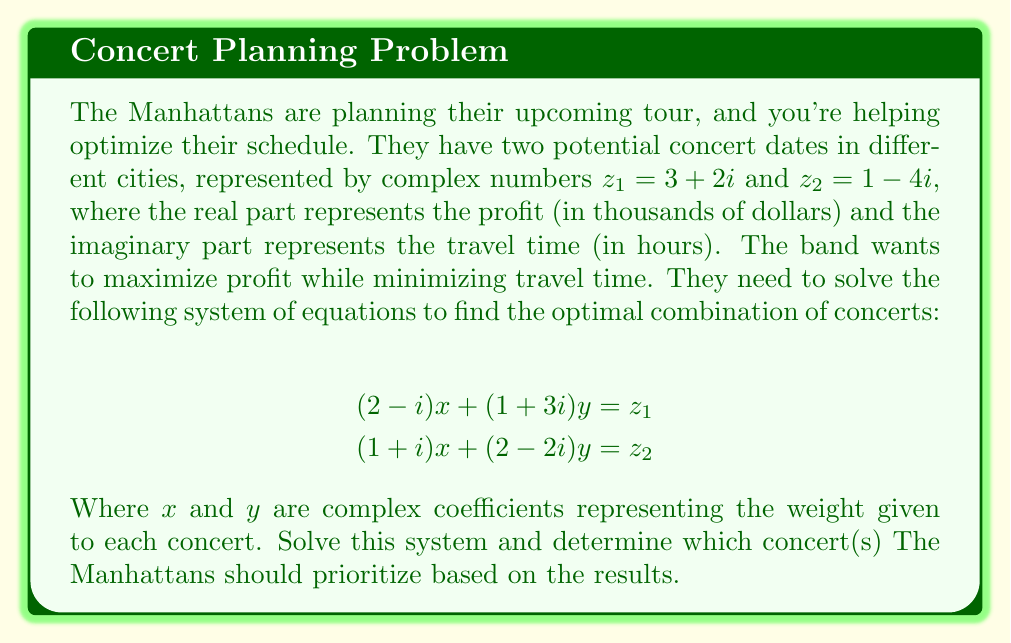What is the answer to this math problem? Let's solve this step-by-step:

1) First, we'll write out the system of equations:
   $$(2-i)x + (1+3i)y = 3+2i$$
   $$(1+i)x + (2-2i)y = 1-4i$$

2) We can solve this using substitution or elimination. Let's use elimination.

3) Multiply the first equation by $(1+i)$ and the second by $(2-i)$:
   $$(2-i)(1+i)x + (1+3i)(1+i)y = (3+2i)(1+i)$$
   $$(1+i)(2-i)x + (2-2i)(2-i)y = (1-4i)(2-i)$$

4) Simplify:
   $$(3+i)x + (-2+4i)y = 1+5i$$
   $$(3+i)x + (6-2i)y = 9-6i$$

5) Subtract the first equation from the second:
   $$(8-6i)y = 8-11i$$

6) Solve for $y$:
   $$y = \frac{8-11i}{8-6i} = \frac{(8-11i)(8+6i)}{(8-6i)(8+6i)} = \frac{64+48i-88i-66i^2}{64+36} = \frac{130-40i}{100} = 1.3-0.4i$$

7) Substitute this value of $y$ back into one of the original equations:
   $$(2-i)x + (1+3i)(1.3-0.4i) = 3+2i$$
   $$(2-i)x + 1.3+3.9i-0.4-1.2i = 3+2i$$
   $$(2-i)x = 3+2i - (0.9+2.7i) = 2.1-0.7i$$

8) Solve for $x$:
   $$x = \frac{2.1-0.7i}{2-i} = \frac{(2.1-0.7i)(2+i)}{(2-i)(2+i)} = \frac{4.2+2.1i-1.4i+0.7}{4+1} = \frac{4.9+0.7i}{5} = 0.98+0.14i$$

Now, let's interpret the results:
- $x = 0.98+0.14i$
- $y = 1.3-0.4i$

The real parts represent the weight given to profit, while the imaginary parts represent the weight given to travel time (negative values indicate a preference for shorter travel times).

Both concerts have positive weights for profit, with the second concert ($y$) having a higher weight. The second concert also has a stronger preference for minimizing travel time.
Answer: Based on the solution, The Manhattans should prioritize the second concert ($z_2$) as it has a higher weight ($y = 1.3-0.4i$) compared to the first concert ($x = 0.98+0.14i$). This suggests that the second concert offers a better balance of higher profit and shorter travel time. 